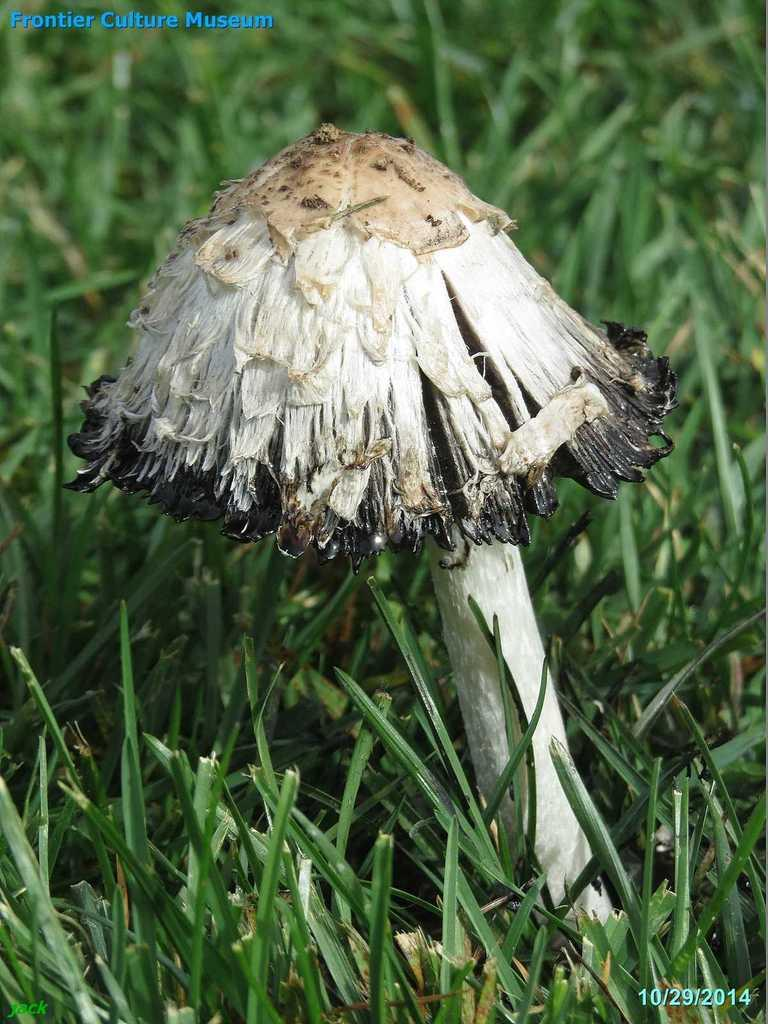What is the main subject of the image? The main subject of the image is a mushroom. What type of vegetation is present at the bottom of the image? There is green grass at the bottom of the image. How many cows are grazing on the grass in the image? There are no cows present in the image; it only features a mushroom and green grass. What type of brush is used to paint the mushroom in the image? The image is not a painting, so there is no brush used to create it. 